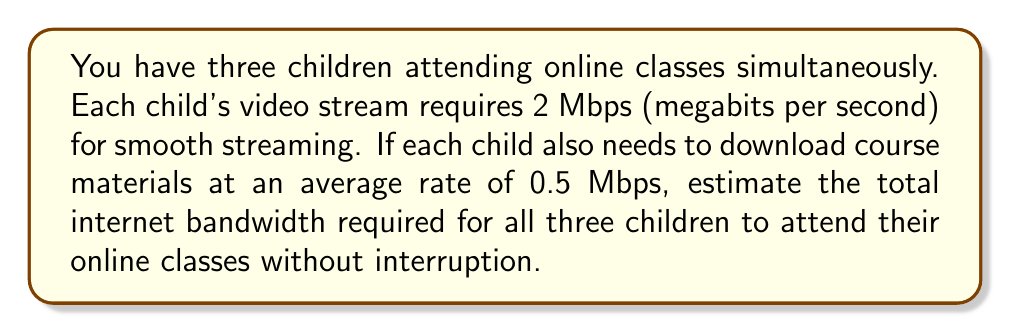Could you help me with this problem? Let's break this down step-by-step:

1. Calculate the bandwidth required for video streaming:
   - Each child needs 2 Mbps for video
   - There are 3 children
   - Total video bandwidth = $3 \times 2$ Mbps = $6$ Mbps

2. Calculate the bandwidth required for downloading materials:
   - Each child needs 0.5 Mbps for downloading
   - There are 3 children
   - Total download bandwidth = $3 \times 0.5$ Mbps = $1.5$ Mbps

3. Sum up the total bandwidth required:
   Total bandwidth = Video bandwidth + Download bandwidth
   $$ \text{Total bandwidth} = 6 \text{ Mbps} + 1.5 \text{ Mbps} = 7.5 \text{ Mbps} $$

Therefore, the estimated total internet bandwidth required for all three children to attend their online classes without interruption is 7.5 Mbps.
Answer: 7.5 Mbps 